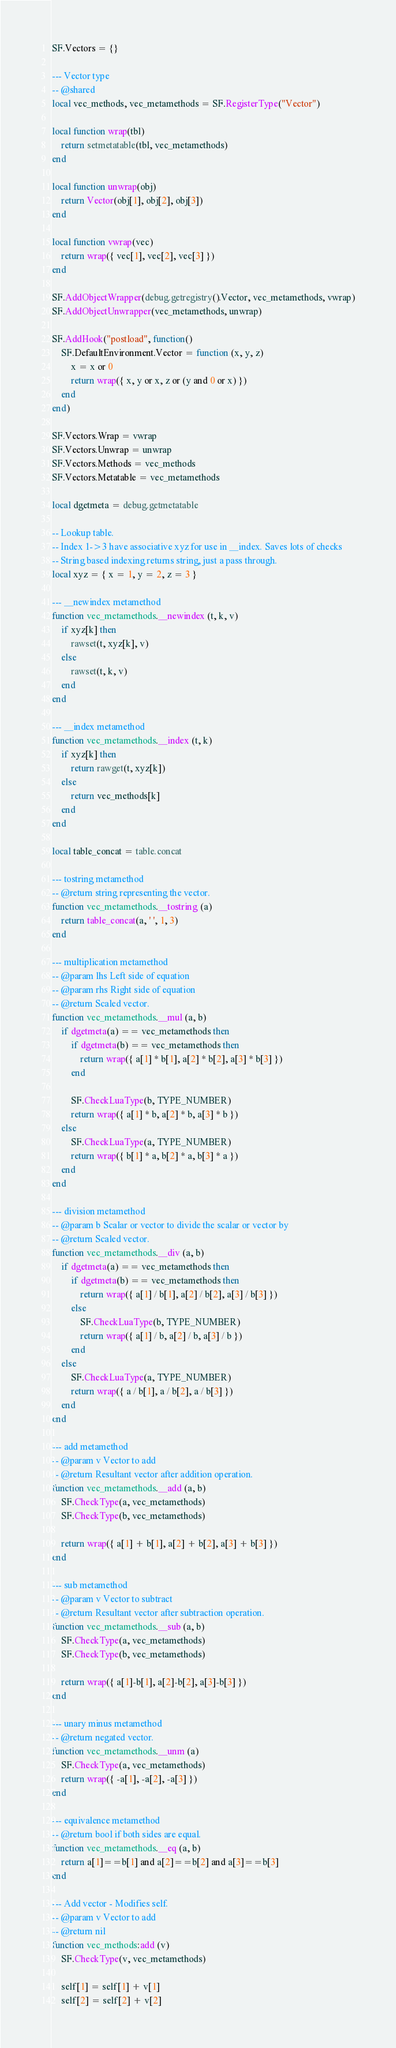Convert code to text. <code><loc_0><loc_0><loc_500><loc_500><_Lua_>SF.Vectors = {}

--- Vector type
-- @shared
local vec_methods, vec_metamethods = SF.RegisterType("Vector")

local function wrap(tbl)
	return setmetatable(tbl, vec_metamethods)
end

local function unwrap(obj)
	return Vector(obj[1], obj[2], obj[3])
end

local function vwrap(vec)
	return wrap({ vec[1], vec[2], vec[3] })
end

SF.AddObjectWrapper(debug.getregistry().Vector, vec_metamethods, vwrap)
SF.AddObjectUnwrapper(vec_metamethods, unwrap)

SF.AddHook("postload", function()
	SF.DefaultEnvironment.Vector = function (x, y, z)
		x = x or 0
		return wrap({ x, y or x, z or (y and 0 or x) })
	end
end)

SF.Vectors.Wrap = vwrap
SF.Vectors.Unwrap = unwrap
SF.Vectors.Methods = vec_methods
SF.Vectors.Metatable = vec_metamethods

local dgetmeta = debug.getmetatable

-- Lookup table.
-- Index 1->3 have associative xyz for use in __index. Saves lots of checks
-- String based indexing returns string, just a pass through.
local xyz = { x = 1, y = 2, z = 3 }

--- __newindex metamethod
function vec_metamethods.__newindex (t, k, v)
	if xyz[k] then
		rawset(t, xyz[k], v)
	else
		rawset(t, k, v)
	end
end

--- __index metamethod
function vec_metamethods.__index (t, k)
	if xyz[k] then
		return rawget(t, xyz[k])
	else
		return vec_methods[k]
	end
end

local table_concat = table.concat

--- tostring metamethod
-- @return string representing the vector.
function vec_metamethods.__tostring (a)
	return table_concat(a, ' ', 1, 3)
end

--- multiplication metamethod
-- @param lhs Left side of equation
-- @param rhs Right side of equation
-- @return Scaled vector.
function vec_metamethods.__mul (a, b)
	if dgetmeta(a) == vec_metamethods then
		if dgetmeta(b) == vec_metamethods then
			return wrap({ a[1] * b[1], a[2] * b[2], a[3] * b[3] })
		end

		SF.CheckLuaType(b, TYPE_NUMBER)
		return wrap({ a[1] * b, a[2] * b, a[3] * b })
	else
		SF.CheckLuaType(a, TYPE_NUMBER)
		return wrap({ b[1] * a, b[2] * a, b[3] * a })
	end
end

--- division metamethod
-- @param b Scalar or vector to divide the scalar or vector by
-- @return Scaled vector.
function vec_metamethods.__div (a, b)
	if dgetmeta(a) == vec_metamethods then
		if dgetmeta(b) == vec_metamethods then
			return wrap({ a[1] / b[1], a[2] / b[2], a[3] / b[3] })
		else
			SF.CheckLuaType(b, TYPE_NUMBER)
			return wrap({ a[1] / b, a[2] / b, a[3] / b })
		end
	else
		SF.CheckLuaType(a, TYPE_NUMBER)
		return wrap({ a / b[1], a / b[2], a / b[3] })
	end
end

--- add metamethod
-- @param v Vector to add
-- @return Resultant vector after addition operation.
function vec_metamethods.__add (a, b)
	SF.CheckType(a, vec_metamethods)
	SF.CheckType(b, vec_metamethods)

	return wrap({ a[1] + b[1], a[2] + b[2], a[3] + b[3] })
end

--- sub metamethod
-- @param v Vector to subtract
-- @return Resultant vector after subtraction operation.
function vec_metamethods.__sub (a, b)
	SF.CheckType(a, vec_metamethods)
	SF.CheckType(b, vec_metamethods)

	return wrap({ a[1]-b[1], a[2]-b[2], a[3]-b[3] })
end

--- unary minus metamethod
-- @return negated vector.
function vec_metamethods.__unm (a)
	SF.CheckType(a, vec_metamethods)
	return wrap({ -a[1], -a[2], -a[3] })
end

--- equivalence metamethod
-- @return bool if both sides are equal.
function vec_metamethods.__eq (a, b)
	return a[1]==b[1] and a[2]==b[2] and a[3]==b[3]
end

--- Add vector - Modifies self.
-- @param v Vector to add
-- @return nil
function vec_methods:add (v)
	SF.CheckType(v, vec_metamethods)

	self[1] = self[1] + v[1]
	self[2] = self[2] + v[2]</code> 